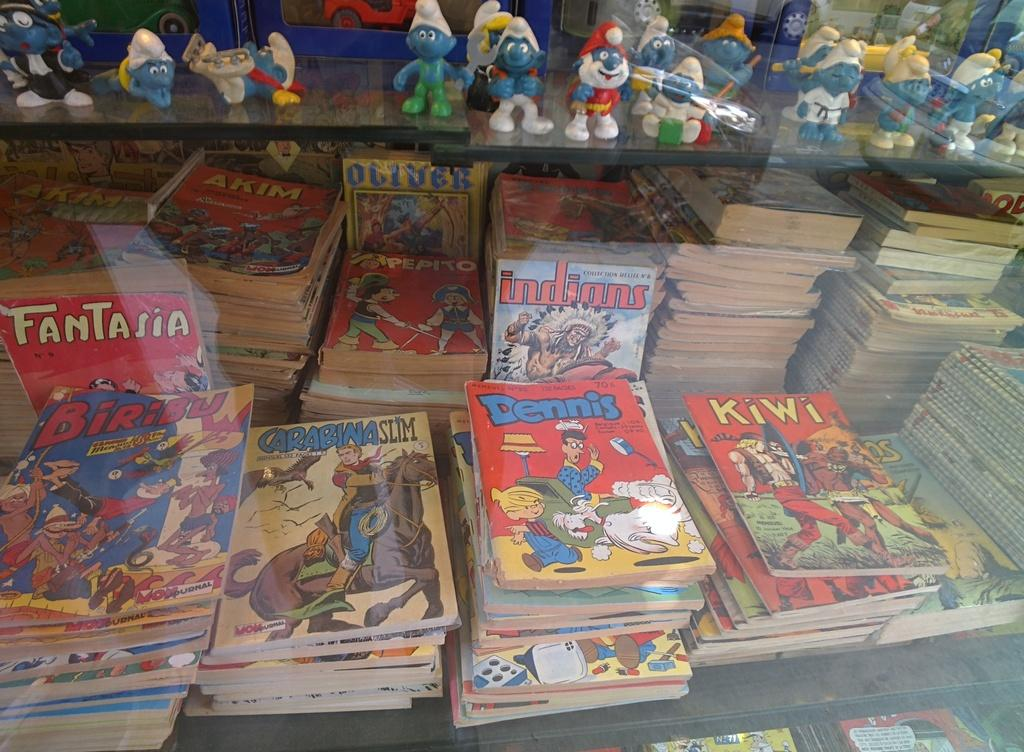<image>
Provide a brief description of the given image. A stack of Carabina Slim comics sits with other comic books under a bunch of Smurf figurines on a shelf. 